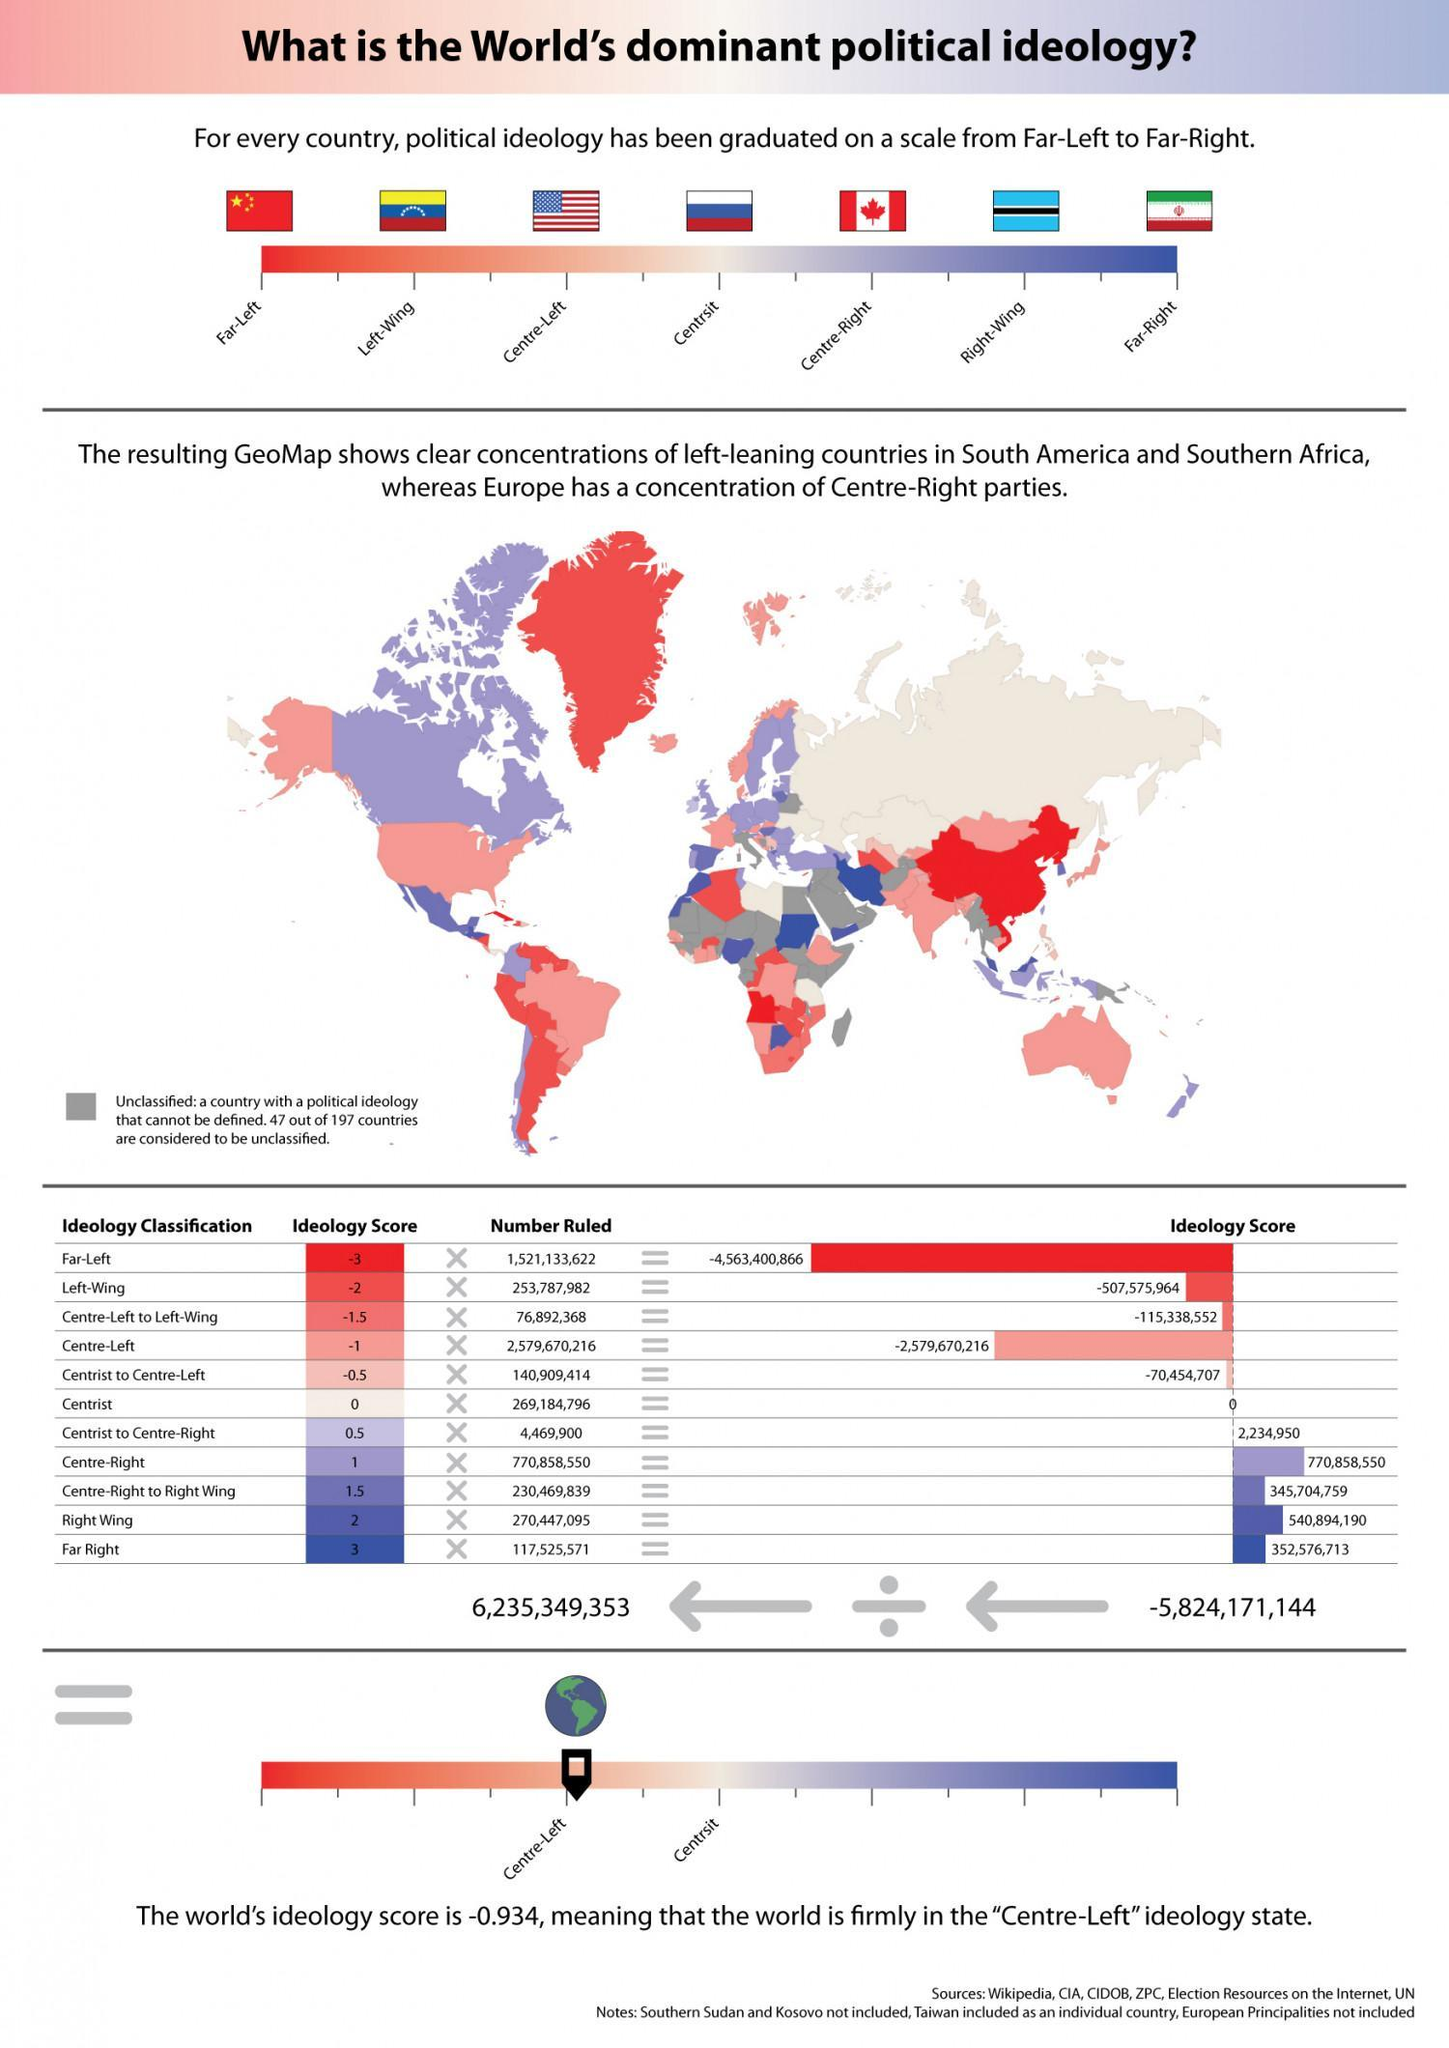Which country has right wing political ideologies, Botswana, US, or Canada?
Answer the question with a short phrase. Botswana What would be the ideology score of China ? -3 Which country has left wing political ideologies, Iran, Venezuela, or US? Venezuela What would be the ideology score of Botswana? 2 What would be the political ideology score of Russia? 0 Which country has far right political ideologies, Canada, Iran, or China? Iran Which country has centrist political ideologies, China, Venezuela, or Russia? Russia 